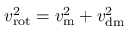Convert formula to latex. <formula><loc_0><loc_0><loc_500><loc_500>v _ { r o t } ^ { 2 } = v _ { m } ^ { 2 } + v _ { d m } ^ { 2 }</formula> 